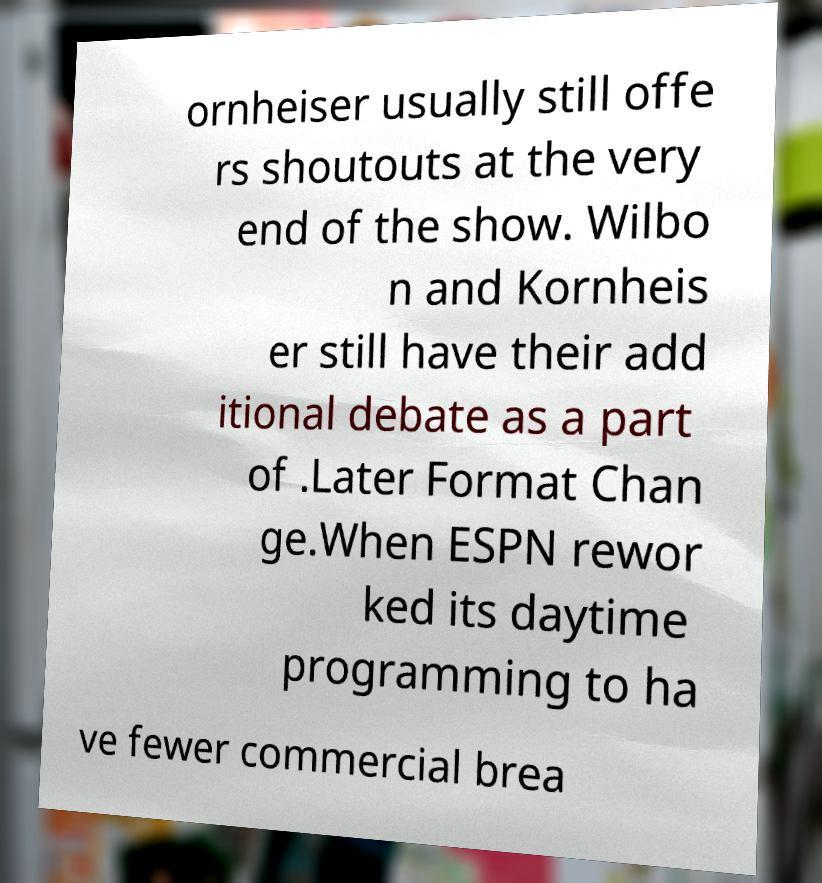I need the written content from this picture converted into text. Can you do that? ornheiser usually still offe rs shoutouts at the very end of the show. Wilbo n and Kornheis er still have their add itional debate as a part of .Later Format Chan ge.When ESPN rewor ked its daytime programming to ha ve fewer commercial brea 